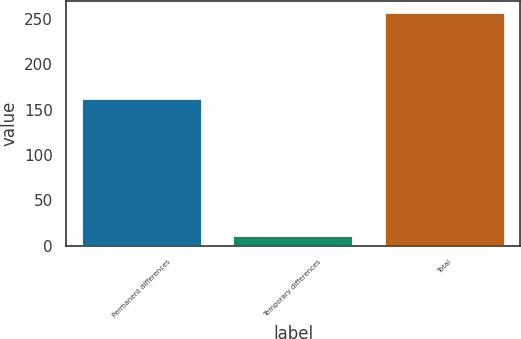Convert chart to OTSL. <chart><loc_0><loc_0><loc_500><loc_500><bar_chart><fcel>Permanent differences<fcel>Temporary differences<fcel>Total<nl><fcel>163<fcel>12<fcel>257<nl></chart> 